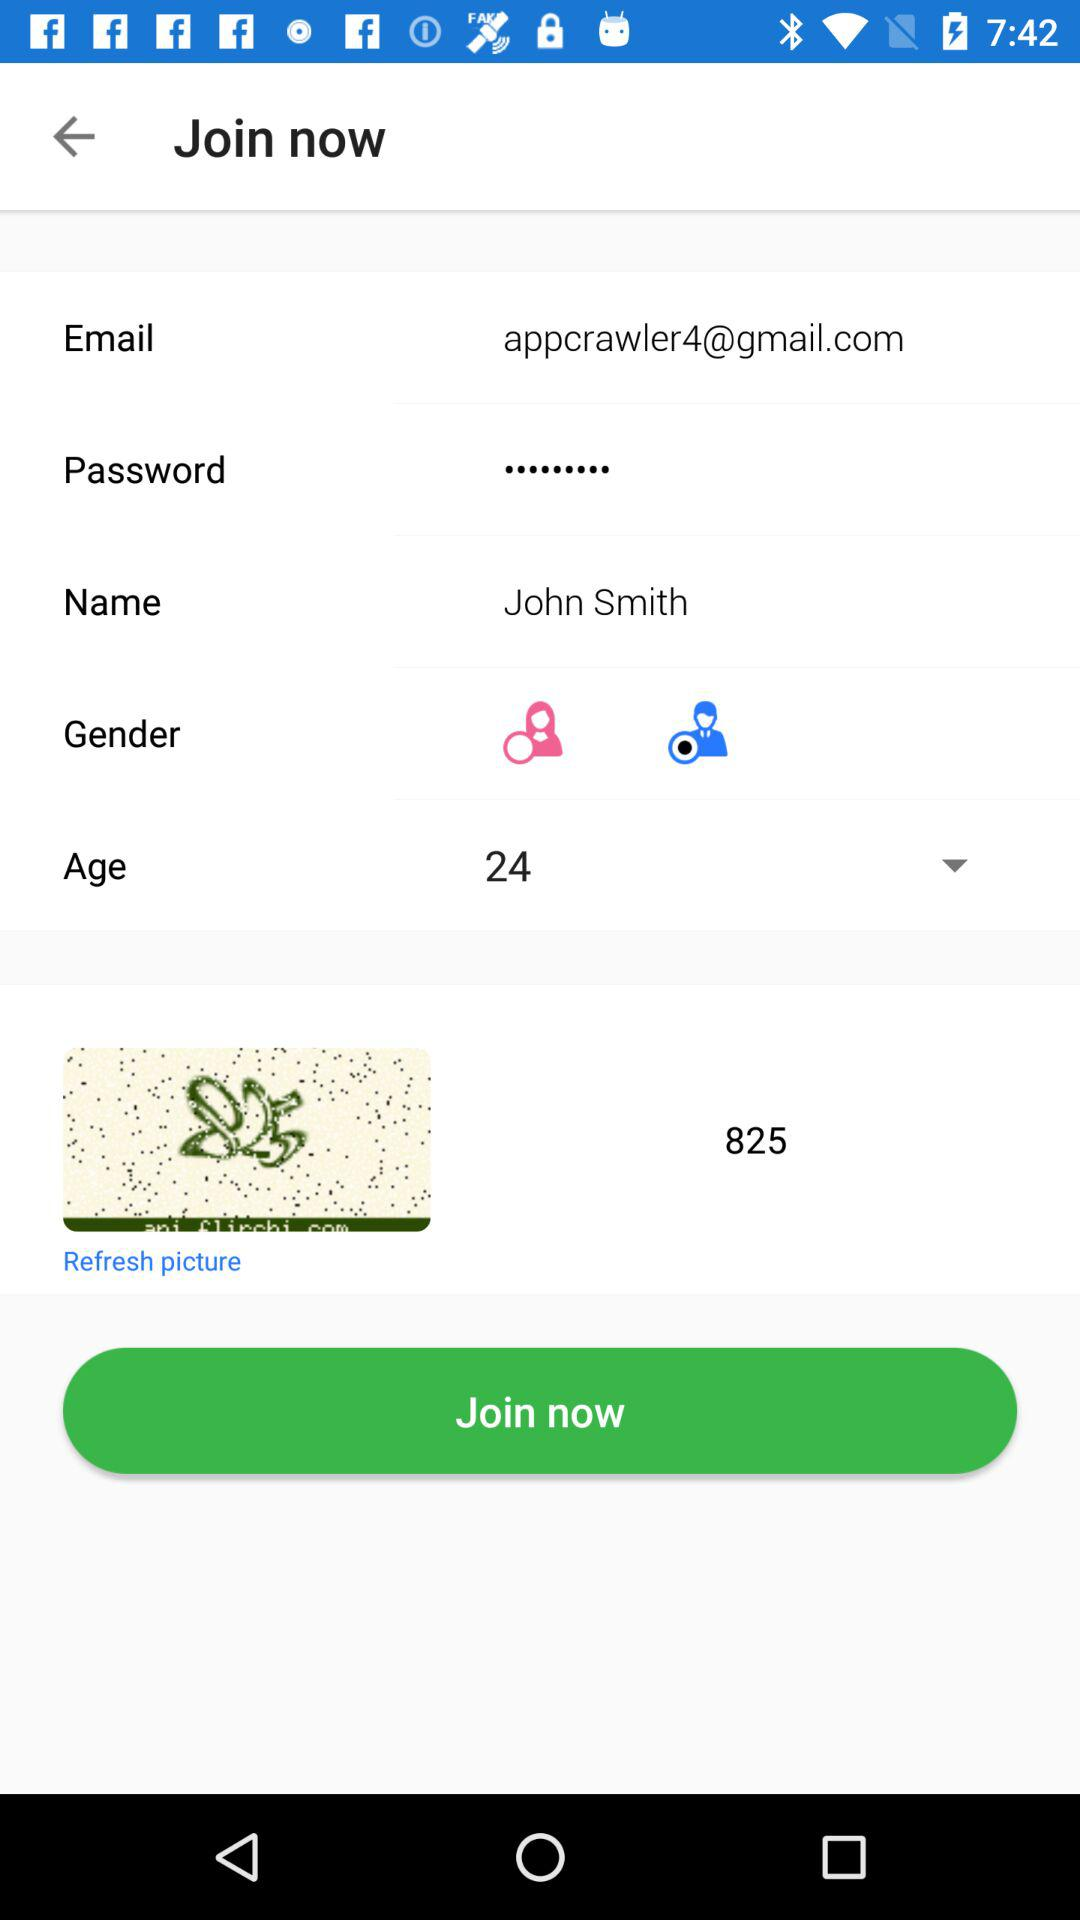What is the user name? The user name is John Smith. 